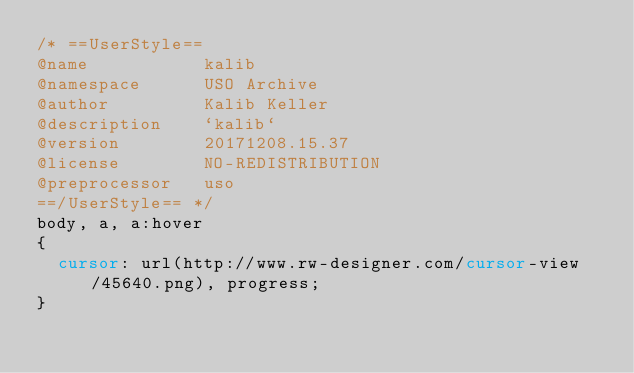Convert code to text. <code><loc_0><loc_0><loc_500><loc_500><_CSS_>/* ==UserStyle==
@name           kalib
@namespace      USO Archive
@author         Kalib Keller
@description    `kalib`
@version        20171208.15.37
@license        NO-REDISTRIBUTION
@preprocessor   uso
==/UserStyle== */
body, a, a:hover
{
  cursor: url(http://www.rw-designer.com/cursor-view/45640.png), progress;
}</code> 